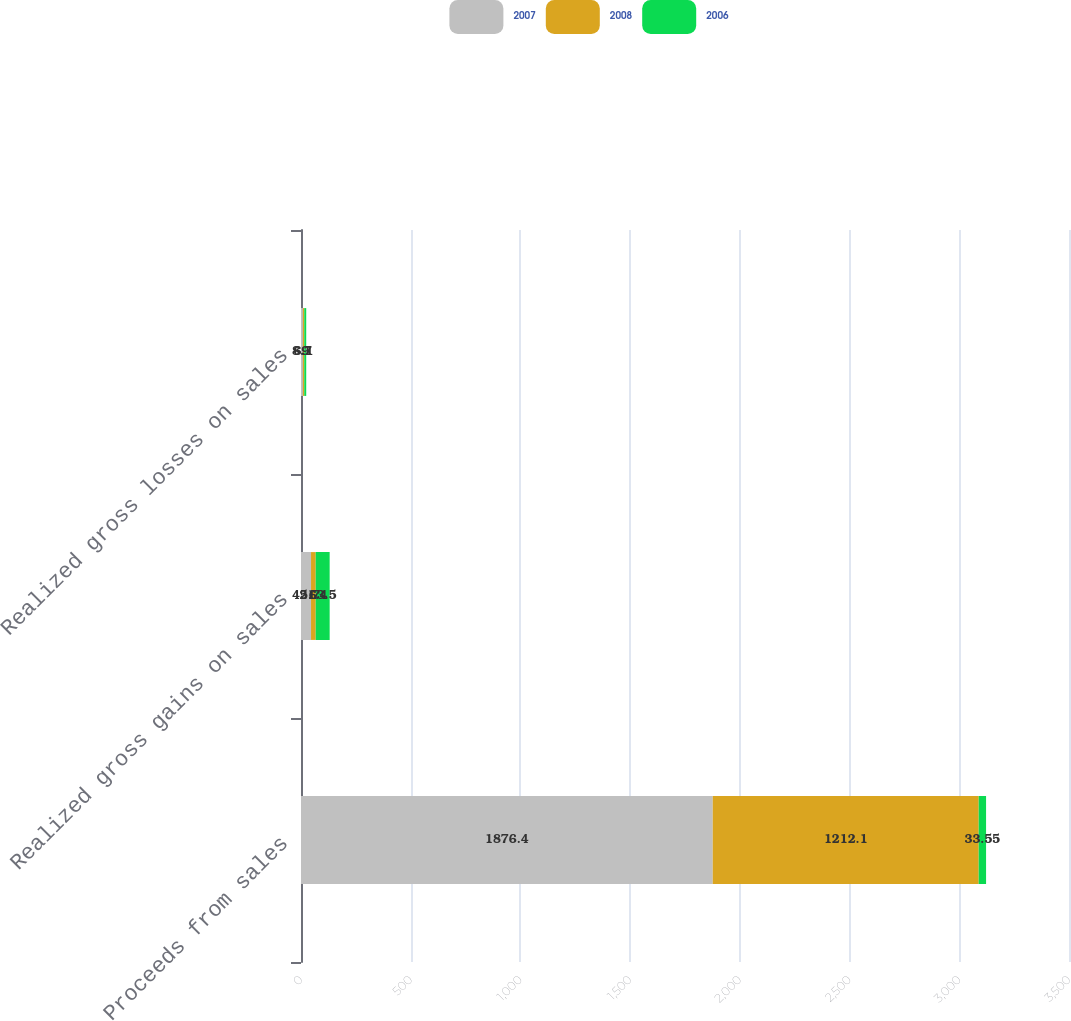<chart> <loc_0><loc_0><loc_500><loc_500><stacked_bar_chart><ecel><fcel>Proceeds from sales<fcel>Realized gross gains on sales<fcel>Realized gross losses on sales<nl><fcel>2007<fcel>1876.4<fcel>45.7<fcel>8.7<nl><fcel>2008<fcel>1212.1<fcel>21.4<fcel>6.1<nl><fcel>2006<fcel>33.55<fcel>63.5<fcel>9<nl></chart> 